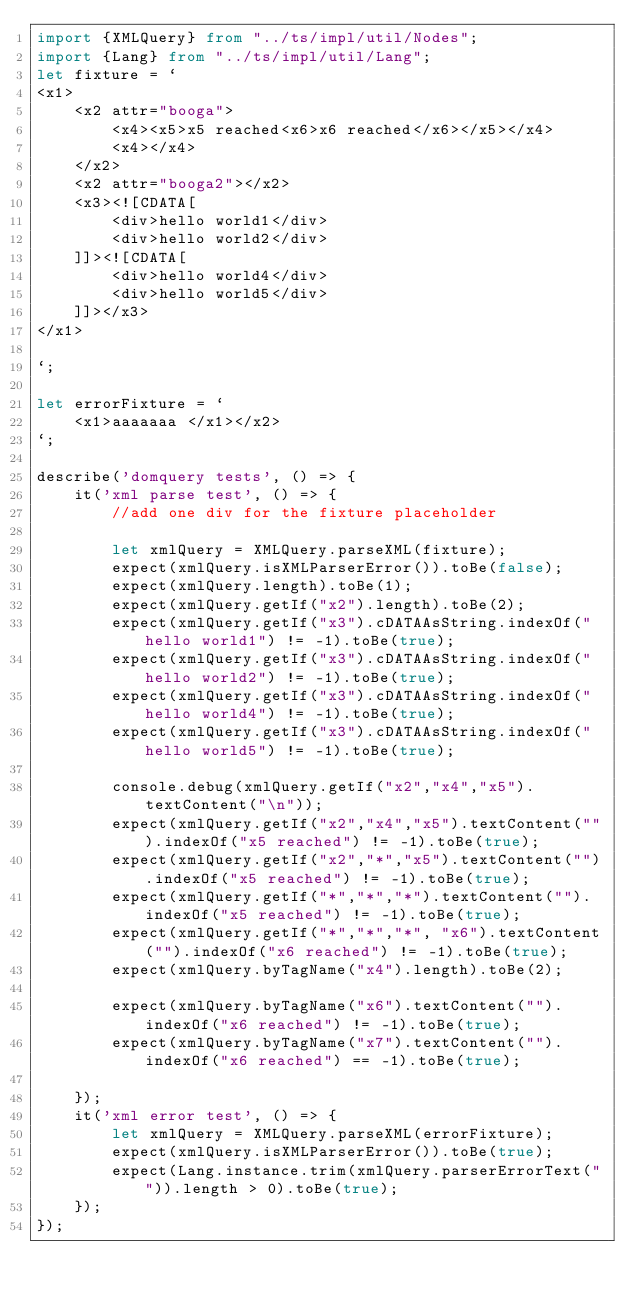Convert code to text. <code><loc_0><loc_0><loc_500><loc_500><_TypeScript_>import {XMLQuery} from "../ts/impl/util/Nodes";
import {Lang} from "../ts/impl/util/Lang";
let fixture = `
<x1>
    <x2 attr="booga">
        <x4><x5>x5 reached<x6>x6 reached</x6></x5></x4>
        <x4></x4>
    </x2>
    <x2 attr="booga2"></x2>
    <x3><![CDATA[
        <div>hello world1</div>
        <div>hello world2</div>
    ]]><![CDATA[
        <div>hello world4</div>
        <div>hello world5</div>
    ]]></x3>
</x1>

`;

let errorFixture = `
    <x1>aaaaaaa </x1></x2>
`;

describe('domquery tests', () => {
    it('xml parse test', () => {
        //add one div for the fixture placeholder

        let xmlQuery = XMLQuery.parseXML(fixture);
        expect(xmlQuery.isXMLParserError()).toBe(false);
        expect(xmlQuery.length).toBe(1);
        expect(xmlQuery.getIf("x2").length).toBe(2);
        expect(xmlQuery.getIf("x3").cDATAAsString.indexOf("hello world1") != -1).toBe(true);
        expect(xmlQuery.getIf("x3").cDATAAsString.indexOf("hello world2") != -1).toBe(true);
        expect(xmlQuery.getIf("x3").cDATAAsString.indexOf("hello world4") != -1).toBe(true);
        expect(xmlQuery.getIf("x3").cDATAAsString.indexOf("hello world5") != -1).toBe(true);

        console.debug(xmlQuery.getIf("x2","x4","x5").textContent("\n"));
        expect(xmlQuery.getIf("x2","x4","x5").textContent("").indexOf("x5 reached") != -1).toBe(true);
        expect(xmlQuery.getIf("x2","*","x5").textContent("").indexOf("x5 reached") != -1).toBe(true);
        expect(xmlQuery.getIf("*","*","*").textContent("").indexOf("x5 reached") != -1).toBe(true);
        expect(xmlQuery.getIf("*","*","*", "x6").textContent("").indexOf("x6 reached") != -1).toBe(true);
        expect(xmlQuery.byTagName("x4").length).toBe(2);

        expect(xmlQuery.byTagName("x6").textContent("").indexOf("x6 reached") != -1).toBe(true);
        expect(xmlQuery.byTagName("x7").textContent("").indexOf("x6 reached") == -1).toBe(true);

    });
    it('xml error test', () => {
        let xmlQuery = XMLQuery.parseXML(errorFixture);
        expect(xmlQuery.isXMLParserError()).toBe(true);
        expect(Lang.instance.trim(xmlQuery.parserErrorText("")).length > 0).toBe(true);
    });
});</code> 